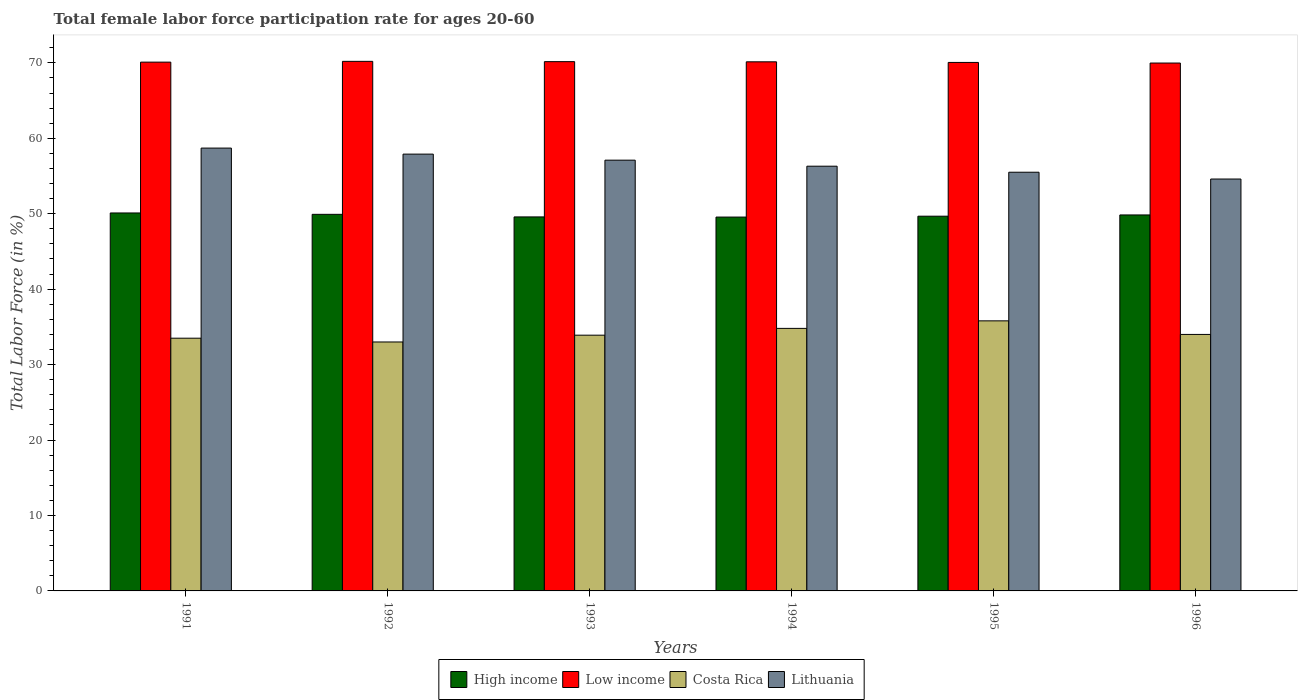How many groups of bars are there?
Provide a short and direct response. 6. Are the number of bars per tick equal to the number of legend labels?
Keep it short and to the point. Yes. Are the number of bars on each tick of the X-axis equal?
Offer a very short reply. Yes. How many bars are there on the 2nd tick from the right?
Your answer should be compact. 4. In how many cases, is the number of bars for a given year not equal to the number of legend labels?
Offer a terse response. 0. What is the female labor force participation rate in Low income in 1995?
Provide a succinct answer. 70.06. Across all years, what is the maximum female labor force participation rate in High income?
Offer a terse response. 50.1. Across all years, what is the minimum female labor force participation rate in High income?
Keep it short and to the point. 49.56. What is the total female labor force participation rate in Low income in the graph?
Your answer should be compact. 420.61. What is the difference between the female labor force participation rate in Low income in 1994 and that in 1996?
Provide a short and direct response. 0.16. What is the difference between the female labor force participation rate in Lithuania in 1991 and the female labor force participation rate in Costa Rica in 1996?
Give a very brief answer. 24.7. What is the average female labor force participation rate in Low income per year?
Make the answer very short. 70.1. In the year 1996, what is the difference between the female labor force participation rate in Lithuania and female labor force participation rate in Costa Rica?
Keep it short and to the point. 20.6. In how many years, is the female labor force participation rate in Low income greater than 12 %?
Keep it short and to the point. 6. What is the ratio of the female labor force participation rate in Low income in 1994 to that in 1996?
Make the answer very short. 1. What is the difference between the highest and the lowest female labor force participation rate in Lithuania?
Offer a terse response. 4.1. What does the 2nd bar from the left in 1991 represents?
Offer a very short reply. Low income. What does the 2nd bar from the right in 1992 represents?
Ensure brevity in your answer.  Costa Rica. Is it the case that in every year, the sum of the female labor force participation rate in High income and female labor force participation rate in Lithuania is greater than the female labor force participation rate in Costa Rica?
Offer a terse response. Yes. What is the difference between two consecutive major ticks on the Y-axis?
Provide a succinct answer. 10. Does the graph contain any zero values?
Your answer should be compact. No. Does the graph contain grids?
Make the answer very short. No. How many legend labels are there?
Offer a terse response. 4. What is the title of the graph?
Your answer should be very brief. Total female labor force participation rate for ages 20-60. Does "Gambia, The" appear as one of the legend labels in the graph?
Offer a very short reply. No. What is the label or title of the Y-axis?
Make the answer very short. Total Labor Force (in %). What is the Total Labor Force (in %) of High income in 1991?
Offer a terse response. 50.1. What is the Total Labor Force (in %) of Low income in 1991?
Keep it short and to the point. 70.09. What is the Total Labor Force (in %) in Costa Rica in 1991?
Provide a succinct answer. 33.5. What is the Total Labor Force (in %) in Lithuania in 1991?
Your answer should be compact. 58.7. What is the Total Labor Force (in %) of High income in 1992?
Provide a succinct answer. 49.92. What is the Total Labor Force (in %) of Low income in 1992?
Your answer should be very brief. 70.2. What is the Total Labor Force (in %) in Lithuania in 1992?
Give a very brief answer. 57.9. What is the Total Labor Force (in %) in High income in 1993?
Keep it short and to the point. 49.58. What is the Total Labor Force (in %) in Low income in 1993?
Provide a short and direct response. 70.16. What is the Total Labor Force (in %) of Costa Rica in 1993?
Your answer should be very brief. 33.9. What is the Total Labor Force (in %) in Lithuania in 1993?
Provide a short and direct response. 57.1. What is the Total Labor Force (in %) in High income in 1994?
Provide a short and direct response. 49.56. What is the Total Labor Force (in %) of Low income in 1994?
Ensure brevity in your answer.  70.14. What is the Total Labor Force (in %) in Costa Rica in 1994?
Provide a succinct answer. 34.8. What is the Total Labor Force (in %) in Lithuania in 1994?
Provide a short and direct response. 56.3. What is the Total Labor Force (in %) in High income in 1995?
Ensure brevity in your answer.  49.67. What is the Total Labor Force (in %) of Low income in 1995?
Give a very brief answer. 70.06. What is the Total Labor Force (in %) in Costa Rica in 1995?
Ensure brevity in your answer.  35.8. What is the Total Labor Force (in %) in Lithuania in 1995?
Your answer should be compact. 55.5. What is the Total Labor Force (in %) of High income in 1996?
Provide a succinct answer. 49.84. What is the Total Labor Force (in %) in Low income in 1996?
Your answer should be compact. 69.97. What is the Total Labor Force (in %) of Costa Rica in 1996?
Ensure brevity in your answer.  34. What is the Total Labor Force (in %) in Lithuania in 1996?
Offer a very short reply. 54.6. Across all years, what is the maximum Total Labor Force (in %) of High income?
Give a very brief answer. 50.1. Across all years, what is the maximum Total Labor Force (in %) of Low income?
Keep it short and to the point. 70.2. Across all years, what is the maximum Total Labor Force (in %) in Costa Rica?
Ensure brevity in your answer.  35.8. Across all years, what is the maximum Total Labor Force (in %) of Lithuania?
Provide a succinct answer. 58.7. Across all years, what is the minimum Total Labor Force (in %) of High income?
Make the answer very short. 49.56. Across all years, what is the minimum Total Labor Force (in %) of Low income?
Make the answer very short. 69.97. Across all years, what is the minimum Total Labor Force (in %) of Costa Rica?
Ensure brevity in your answer.  33. Across all years, what is the minimum Total Labor Force (in %) in Lithuania?
Your response must be concise. 54.6. What is the total Total Labor Force (in %) of High income in the graph?
Ensure brevity in your answer.  298.66. What is the total Total Labor Force (in %) of Low income in the graph?
Give a very brief answer. 420.61. What is the total Total Labor Force (in %) in Costa Rica in the graph?
Make the answer very short. 205. What is the total Total Labor Force (in %) in Lithuania in the graph?
Offer a very short reply. 340.1. What is the difference between the Total Labor Force (in %) of High income in 1991 and that in 1992?
Provide a succinct answer. 0.18. What is the difference between the Total Labor Force (in %) of Low income in 1991 and that in 1992?
Your response must be concise. -0.1. What is the difference between the Total Labor Force (in %) in Costa Rica in 1991 and that in 1992?
Keep it short and to the point. 0.5. What is the difference between the Total Labor Force (in %) of High income in 1991 and that in 1993?
Your answer should be compact. 0.52. What is the difference between the Total Labor Force (in %) of Low income in 1991 and that in 1993?
Keep it short and to the point. -0.06. What is the difference between the Total Labor Force (in %) in Lithuania in 1991 and that in 1993?
Ensure brevity in your answer.  1.6. What is the difference between the Total Labor Force (in %) in High income in 1991 and that in 1994?
Ensure brevity in your answer.  0.54. What is the difference between the Total Labor Force (in %) of Low income in 1991 and that in 1994?
Offer a terse response. -0.04. What is the difference between the Total Labor Force (in %) of Costa Rica in 1991 and that in 1994?
Make the answer very short. -1.3. What is the difference between the Total Labor Force (in %) in Lithuania in 1991 and that in 1994?
Give a very brief answer. 2.4. What is the difference between the Total Labor Force (in %) in High income in 1991 and that in 1995?
Keep it short and to the point. 0.43. What is the difference between the Total Labor Force (in %) of Low income in 1991 and that in 1995?
Provide a short and direct response. 0.04. What is the difference between the Total Labor Force (in %) in Costa Rica in 1991 and that in 1995?
Provide a short and direct response. -2.3. What is the difference between the Total Labor Force (in %) of High income in 1991 and that in 1996?
Ensure brevity in your answer.  0.26. What is the difference between the Total Labor Force (in %) in Low income in 1991 and that in 1996?
Offer a terse response. 0.12. What is the difference between the Total Labor Force (in %) in Costa Rica in 1991 and that in 1996?
Offer a very short reply. -0.5. What is the difference between the Total Labor Force (in %) in Lithuania in 1991 and that in 1996?
Offer a terse response. 4.1. What is the difference between the Total Labor Force (in %) in High income in 1992 and that in 1993?
Ensure brevity in your answer.  0.34. What is the difference between the Total Labor Force (in %) of Low income in 1992 and that in 1993?
Keep it short and to the point. 0.04. What is the difference between the Total Labor Force (in %) of High income in 1992 and that in 1994?
Provide a short and direct response. 0.36. What is the difference between the Total Labor Force (in %) of Low income in 1992 and that in 1994?
Keep it short and to the point. 0.06. What is the difference between the Total Labor Force (in %) of Costa Rica in 1992 and that in 1994?
Provide a succinct answer. -1.8. What is the difference between the Total Labor Force (in %) of High income in 1992 and that in 1995?
Offer a very short reply. 0.25. What is the difference between the Total Labor Force (in %) in Low income in 1992 and that in 1995?
Offer a very short reply. 0.14. What is the difference between the Total Labor Force (in %) of Costa Rica in 1992 and that in 1995?
Your response must be concise. -2.8. What is the difference between the Total Labor Force (in %) of Lithuania in 1992 and that in 1995?
Make the answer very short. 2.4. What is the difference between the Total Labor Force (in %) in High income in 1992 and that in 1996?
Your answer should be very brief. 0.08. What is the difference between the Total Labor Force (in %) of Low income in 1992 and that in 1996?
Give a very brief answer. 0.22. What is the difference between the Total Labor Force (in %) in Costa Rica in 1992 and that in 1996?
Offer a terse response. -1. What is the difference between the Total Labor Force (in %) of High income in 1993 and that in 1994?
Provide a short and direct response. 0.02. What is the difference between the Total Labor Force (in %) of Low income in 1993 and that in 1994?
Offer a terse response. 0.02. What is the difference between the Total Labor Force (in %) in Lithuania in 1993 and that in 1994?
Keep it short and to the point. 0.8. What is the difference between the Total Labor Force (in %) in High income in 1993 and that in 1995?
Your response must be concise. -0.1. What is the difference between the Total Labor Force (in %) in Low income in 1993 and that in 1995?
Provide a succinct answer. 0.1. What is the difference between the Total Labor Force (in %) in Costa Rica in 1993 and that in 1995?
Your answer should be very brief. -1.9. What is the difference between the Total Labor Force (in %) in Lithuania in 1993 and that in 1995?
Provide a short and direct response. 1.6. What is the difference between the Total Labor Force (in %) of High income in 1993 and that in 1996?
Keep it short and to the point. -0.26. What is the difference between the Total Labor Force (in %) of Low income in 1993 and that in 1996?
Give a very brief answer. 0.18. What is the difference between the Total Labor Force (in %) of High income in 1994 and that in 1995?
Your answer should be compact. -0.12. What is the difference between the Total Labor Force (in %) of Low income in 1994 and that in 1995?
Provide a succinct answer. 0.08. What is the difference between the Total Labor Force (in %) in Costa Rica in 1994 and that in 1995?
Offer a very short reply. -1. What is the difference between the Total Labor Force (in %) of Lithuania in 1994 and that in 1995?
Your answer should be very brief. 0.8. What is the difference between the Total Labor Force (in %) of High income in 1994 and that in 1996?
Give a very brief answer. -0.28. What is the difference between the Total Labor Force (in %) in Low income in 1994 and that in 1996?
Keep it short and to the point. 0.16. What is the difference between the Total Labor Force (in %) in Lithuania in 1994 and that in 1996?
Your response must be concise. 1.7. What is the difference between the Total Labor Force (in %) of High income in 1995 and that in 1996?
Your answer should be compact. -0.17. What is the difference between the Total Labor Force (in %) in Low income in 1995 and that in 1996?
Offer a very short reply. 0.08. What is the difference between the Total Labor Force (in %) of Costa Rica in 1995 and that in 1996?
Make the answer very short. 1.8. What is the difference between the Total Labor Force (in %) of High income in 1991 and the Total Labor Force (in %) of Low income in 1992?
Your response must be concise. -20.1. What is the difference between the Total Labor Force (in %) in Low income in 1991 and the Total Labor Force (in %) in Costa Rica in 1992?
Your answer should be compact. 37.09. What is the difference between the Total Labor Force (in %) of Low income in 1991 and the Total Labor Force (in %) of Lithuania in 1992?
Your response must be concise. 12.19. What is the difference between the Total Labor Force (in %) of Costa Rica in 1991 and the Total Labor Force (in %) of Lithuania in 1992?
Your response must be concise. -24.4. What is the difference between the Total Labor Force (in %) in High income in 1991 and the Total Labor Force (in %) in Low income in 1993?
Offer a very short reply. -20.06. What is the difference between the Total Labor Force (in %) in High income in 1991 and the Total Labor Force (in %) in Costa Rica in 1993?
Provide a succinct answer. 16.2. What is the difference between the Total Labor Force (in %) of Low income in 1991 and the Total Labor Force (in %) of Costa Rica in 1993?
Ensure brevity in your answer.  36.19. What is the difference between the Total Labor Force (in %) in Low income in 1991 and the Total Labor Force (in %) in Lithuania in 1993?
Give a very brief answer. 12.99. What is the difference between the Total Labor Force (in %) of Costa Rica in 1991 and the Total Labor Force (in %) of Lithuania in 1993?
Your answer should be very brief. -23.6. What is the difference between the Total Labor Force (in %) of High income in 1991 and the Total Labor Force (in %) of Low income in 1994?
Offer a very short reply. -20.04. What is the difference between the Total Labor Force (in %) in High income in 1991 and the Total Labor Force (in %) in Lithuania in 1994?
Ensure brevity in your answer.  -6.2. What is the difference between the Total Labor Force (in %) of Low income in 1991 and the Total Labor Force (in %) of Costa Rica in 1994?
Offer a terse response. 35.29. What is the difference between the Total Labor Force (in %) of Low income in 1991 and the Total Labor Force (in %) of Lithuania in 1994?
Offer a terse response. 13.79. What is the difference between the Total Labor Force (in %) of Costa Rica in 1991 and the Total Labor Force (in %) of Lithuania in 1994?
Offer a terse response. -22.8. What is the difference between the Total Labor Force (in %) of High income in 1991 and the Total Labor Force (in %) of Low income in 1995?
Offer a terse response. -19.96. What is the difference between the Total Labor Force (in %) of High income in 1991 and the Total Labor Force (in %) of Costa Rica in 1995?
Provide a short and direct response. 14.3. What is the difference between the Total Labor Force (in %) of Low income in 1991 and the Total Labor Force (in %) of Costa Rica in 1995?
Your answer should be very brief. 34.29. What is the difference between the Total Labor Force (in %) of Low income in 1991 and the Total Labor Force (in %) of Lithuania in 1995?
Offer a very short reply. 14.59. What is the difference between the Total Labor Force (in %) of High income in 1991 and the Total Labor Force (in %) of Low income in 1996?
Provide a short and direct response. -19.87. What is the difference between the Total Labor Force (in %) in High income in 1991 and the Total Labor Force (in %) in Costa Rica in 1996?
Your answer should be compact. 16.1. What is the difference between the Total Labor Force (in %) in High income in 1991 and the Total Labor Force (in %) in Lithuania in 1996?
Provide a short and direct response. -4.5. What is the difference between the Total Labor Force (in %) in Low income in 1991 and the Total Labor Force (in %) in Costa Rica in 1996?
Offer a very short reply. 36.09. What is the difference between the Total Labor Force (in %) in Low income in 1991 and the Total Labor Force (in %) in Lithuania in 1996?
Your answer should be very brief. 15.49. What is the difference between the Total Labor Force (in %) in Costa Rica in 1991 and the Total Labor Force (in %) in Lithuania in 1996?
Make the answer very short. -21.1. What is the difference between the Total Labor Force (in %) in High income in 1992 and the Total Labor Force (in %) in Low income in 1993?
Provide a succinct answer. -20.24. What is the difference between the Total Labor Force (in %) in High income in 1992 and the Total Labor Force (in %) in Costa Rica in 1993?
Your answer should be very brief. 16.02. What is the difference between the Total Labor Force (in %) of High income in 1992 and the Total Labor Force (in %) of Lithuania in 1993?
Provide a short and direct response. -7.18. What is the difference between the Total Labor Force (in %) of Low income in 1992 and the Total Labor Force (in %) of Costa Rica in 1993?
Your answer should be very brief. 36.3. What is the difference between the Total Labor Force (in %) in Low income in 1992 and the Total Labor Force (in %) in Lithuania in 1993?
Provide a succinct answer. 13.1. What is the difference between the Total Labor Force (in %) of Costa Rica in 1992 and the Total Labor Force (in %) of Lithuania in 1993?
Your response must be concise. -24.1. What is the difference between the Total Labor Force (in %) in High income in 1992 and the Total Labor Force (in %) in Low income in 1994?
Your answer should be very brief. -20.22. What is the difference between the Total Labor Force (in %) in High income in 1992 and the Total Labor Force (in %) in Costa Rica in 1994?
Make the answer very short. 15.12. What is the difference between the Total Labor Force (in %) in High income in 1992 and the Total Labor Force (in %) in Lithuania in 1994?
Offer a terse response. -6.38. What is the difference between the Total Labor Force (in %) of Low income in 1992 and the Total Labor Force (in %) of Costa Rica in 1994?
Make the answer very short. 35.4. What is the difference between the Total Labor Force (in %) of Low income in 1992 and the Total Labor Force (in %) of Lithuania in 1994?
Offer a very short reply. 13.9. What is the difference between the Total Labor Force (in %) in Costa Rica in 1992 and the Total Labor Force (in %) in Lithuania in 1994?
Your response must be concise. -23.3. What is the difference between the Total Labor Force (in %) of High income in 1992 and the Total Labor Force (in %) of Low income in 1995?
Offer a terse response. -20.14. What is the difference between the Total Labor Force (in %) of High income in 1992 and the Total Labor Force (in %) of Costa Rica in 1995?
Your response must be concise. 14.12. What is the difference between the Total Labor Force (in %) in High income in 1992 and the Total Labor Force (in %) in Lithuania in 1995?
Provide a short and direct response. -5.58. What is the difference between the Total Labor Force (in %) in Low income in 1992 and the Total Labor Force (in %) in Costa Rica in 1995?
Provide a succinct answer. 34.4. What is the difference between the Total Labor Force (in %) in Low income in 1992 and the Total Labor Force (in %) in Lithuania in 1995?
Your answer should be compact. 14.7. What is the difference between the Total Labor Force (in %) in Costa Rica in 1992 and the Total Labor Force (in %) in Lithuania in 1995?
Keep it short and to the point. -22.5. What is the difference between the Total Labor Force (in %) in High income in 1992 and the Total Labor Force (in %) in Low income in 1996?
Offer a terse response. -20.06. What is the difference between the Total Labor Force (in %) of High income in 1992 and the Total Labor Force (in %) of Costa Rica in 1996?
Offer a very short reply. 15.92. What is the difference between the Total Labor Force (in %) of High income in 1992 and the Total Labor Force (in %) of Lithuania in 1996?
Your answer should be compact. -4.68. What is the difference between the Total Labor Force (in %) in Low income in 1992 and the Total Labor Force (in %) in Costa Rica in 1996?
Your response must be concise. 36.2. What is the difference between the Total Labor Force (in %) in Low income in 1992 and the Total Labor Force (in %) in Lithuania in 1996?
Your answer should be compact. 15.6. What is the difference between the Total Labor Force (in %) in Costa Rica in 1992 and the Total Labor Force (in %) in Lithuania in 1996?
Give a very brief answer. -21.6. What is the difference between the Total Labor Force (in %) of High income in 1993 and the Total Labor Force (in %) of Low income in 1994?
Offer a terse response. -20.56. What is the difference between the Total Labor Force (in %) of High income in 1993 and the Total Labor Force (in %) of Costa Rica in 1994?
Keep it short and to the point. 14.78. What is the difference between the Total Labor Force (in %) of High income in 1993 and the Total Labor Force (in %) of Lithuania in 1994?
Keep it short and to the point. -6.72. What is the difference between the Total Labor Force (in %) in Low income in 1993 and the Total Labor Force (in %) in Costa Rica in 1994?
Provide a short and direct response. 35.36. What is the difference between the Total Labor Force (in %) of Low income in 1993 and the Total Labor Force (in %) of Lithuania in 1994?
Offer a terse response. 13.86. What is the difference between the Total Labor Force (in %) of Costa Rica in 1993 and the Total Labor Force (in %) of Lithuania in 1994?
Give a very brief answer. -22.4. What is the difference between the Total Labor Force (in %) in High income in 1993 and the Total Labor Force (in %) in Low income in 1995?
Offer a terse response. -20.48. What is the difference between the Total Labor Force (in %) in High income in 1993 and the Total Labor Force (in %) in Costa Rica in 1995?
Offer a terse response. 13.78. What is the difference between the Total Labor Force (in %) in High income in 1993 and the Total Labor Force (in %) in Lithuania in 1995?
Keep it short and to the point. -5.92. What is the difference between the Total Labor Force (in %) of Low income in 1993 and the Total Labor Force (in %) of Costa Rica in 1995?
Provide a succinct answer. 34.36. What is the difference between the Total Labor Force (in %) in Low income in 1993 and the Total Labor Force (in %) in Lithuania in 1995?
Your answer should be compact. 14.66. What is the difference between the Total Labor Force (in %) in Costa Rica in 1993 and the Total Labor Force (in %) in Lithuania in 1995?
Provide a succinct answer. -21.6. What is the difference between the Total Labor Force (in %) in High income in 1993 and the Total Labor Force (in %) in Low income in 1996?
Offer a terse response. -20.4. What is the difference between the Total Labor Force (in %) of High income in 1993 and the Total Labor Force (in %) of Costa Rica in 1996?
Offer a terse response. 15.58. What is the difference between the Total Labor Force (in %) of High income in 1993 and the Total Labor Force (in %) of Lithuania in 1996?
Keep it short and to the point. -5.02. What is the difference between the Total Labor Force (in %) in Low income in 1993 and the Total Labor Force (in %) in Costa Rica in 1996?
Keep it short and to the point. 36.16. What is the difference between the Total Labor Force (in %) in Low income in 1993 and the Total Labor Force (in %) in Lithuania in 1996?
Your answer should be very brief. 15.56. What is the difference between the Total Labor Force (in %) of Costa Rica in 1993 and the Total Labor Force (in %) of Lithuania in 1996?
Give a very brief answer. -20.7. What is the difference between the Total Labor Force (in %) in High income in 1994 and the Total Labor Force (in %) in Low income in 1995?
Offer a very short reply. -20.5. What is the difference between the Total Labor Force (in %) in High income in 1994 and the Total Labor Force (in %) in Costa Rica in 1995?
Offer a terse response. 13.76. What is the difference between the Total Labor Force (in %) of High income in 1994 and the Total Labor Force (in %) of Lithuania in 1995?
Your answer should be compact. -5.94. What is the difference between the Total Labor Force (in %) of Low income in 1994 and the Total Labor Force (in %) of Costa Rica in 1995?
Provide a succinct answer. 34.34. What is the difference between the Total Labor Force (in %) of Low income in 1994 and the Total Labor Force (in %) of Lithuania in 1995?
Keep it short and to the point. 14.64. What is the difference between the Total Labor Force (in %) of Costa Rica in 1994 and the Total Labor Force (in %) of Lithuania in 1995?
Offer a terse response. -20.7. What is the difference between the Total Labor Force (in %) in High income in 1994 and the Total Labor Force (in %) in Low income in 1996?
Offer a very short reply. -20.42. What is the difference between the Total Labor Force (in %) in High income in 1994 and the Total Labor Force (in %) in Costa Rica in 1996?
Offer a very short reply. 15.56. What is the difference between the Total Labor Force (in %) in High income in 1994 and the Total Labor Force (in %) in Lithuania in 1996?
Ensure brevity in your answer.  -5.04. What is the difference between the Total Labor Force (in %) of Low income in 1994 and the Total Labor Force (in %) of Costa Rica in 1996?
Make the answer very short. 36.14. What is the difference between the Total Labor Force (in %) in Low income in 1994 and the Total Labor Force (in %) in Lithuania in 1996?
Provide a succinct answer. 15.54. What is the difference between the Total Labor Force (in %) of Costa Rica in 1994 and the Total Labor Force (in %) of Lithuania in 1996?
Provide a succinct answer. -19.8. What is the difference between the Total Labor Force (in %) in High income in 1995 and the Total Labor Force (in %) in Low income in 1996?
Your response must be concise. -20.3. What is the difference between the Total Labor Force (in %) in High income in 1995 and the Total Labor Force (in %) in Costa Rica in 1996?
Ensure brevity in your answer.  15.67. What is the difference between the Total Labor Force (in %) in High income in 1995 and the Total Labor Force (in %) in Lithuania in 1996?
Make the answer very short. -4.93. What is the difference between the Total Labor Force (in %) in Low income in 1995 and the Total Labor Force (in %) in Costa Rica in 1996?
Provide a succinct answer. 36.06. What is the difference between the Total Labor Force (in %) in Low income in 1995 and the Total Labor Force (in %) in Lithuania in 1996?
Ensure brevity in your answer.  15.46. What is the difference between the Total Labor Force (in %) of Costa Rica in 1995 and the Total Labor Force (in %) of Lithuania in 1996?
Provide a succinct answer. -18.8. What is the average Total Labor Force (in %) of High income per year?
Give a very brief answer. 49.78. What is the average Total Labor Force (in %) in Low income per year?
Provide a succinct answer. 70.1. What is the average Total Labor Force (in %) in Costa Rica per year?
Give a very brief answer. 34.17. What is the average Total Labor Force (in %) in Lithuania per year?
Your answer should be compact. 56.68. In the year 1991, what is the difference between the Total Labor Force (in %) of High income and Total Labor Force (in %) of Low income?
Offer a terse response. -19.99. In the year 1991, what is the difference between the Total Labor Force (in %) of Low income and Total Labor Force (in %) of Costa Rica?
Make the answer very short. 36.59. In the year 1991, what is the difference between the Total Labor Force (in %) in Low income and Total Labor Force (in %) in Lithuania?
Your response must be concise. 11.39. In the year 1991, what is the difference between the Total Labor Force (in %) of Costa Rica and Total Labor Force (in %) of Lithuania?
Provide a succinct answer. -25.2. In the year 1992, what is the difference between the Total Labor Force (in %) in High income and Total Labor Force (in %) in Low income?
Your answer should be very brief. -20.28. In the year 1992, what is the difference between the Total Labor Force (in %) in High income and Total Labor Force (in %) in Costa Rica?
Make the answer very short. 16.92. In the year 1992, what is the difference between the Total Labor Force (in %) of High income and Total Labor Force (in %) of Lithuania?
Your response must be concise. -7.98. In the year 1992, what is the difference between the Total Labor Force (in %) in Low income and Total Labor Force (in %) in Costa Rica?
Keep it short and to the point. 37.2. In the year 1992, what is the difference between the Total Labor Force (in %) in Low income and Total Labor Force (in %) in Lithuania?
Your answer should be very brief. 12.3. In the year 1992, what is the difference between the Total Labor Force (in %) in Costa Rica and Total Labor Force (in %) in Lithuania?
Your answer should be very brief. -24.9. In the year 1993, what is the difference between the Total Labor Force (in %) of High income and Total Labor Force (in %) of Low income?
Offer a terse response. -20.58. In the year 1993, what is the difference between the Total Labor Force (in %) in High income and Total Labor Force (in %) in Costa Rica?
Provide a short and direct response. 15.68. In the year 1993, what is the difference between the Total Labor Force (in %) of High income and Total Labor Force (in %) of Lithuania?
Your response must be concise. -7.52. In the year 1993, what is the difference between the Total Labor Force (in %) of Low income and Total Labor Force (in %) of Costa Rica?
Your answer should be very brief. 36.26. In the year 1993, what is the difference between the Total Labor Force (in %) of Low income and Total Labor Force (in %) of Lithuania?
Provide a succinct answer. 13.06. In the year 1993, what is the difference between the Total Labor Force (in %) of Costa Rica and Total Labor Force (in %) of Lithuania?
Provide a short and direct response. -23.2. In the year 1994, what is the difference between the Total Labor Force (in %) in High income and Total Labor Force (in %) in Low income?
Make the answer very short. -20.58. In the year 1994, what is the difference between the Total Labor Force (in %) in High income and Total Labor Force (in %) in Costa Rica?
Ensure brevity in your answer.  14.76. In the year 1994, what is the difference between the Total Labor Force (in %) in High income and Total Labor Force (in %) in Lithuania?
Make the answer very short. -6.74. In the year 1994, what is the difference between the Total Labor Force (in %) in Low income and Total Labor Force (in %) in Costa Rica?
Make the answer very short. 35.34. In the year 1994, what is the difference between the Total Labor Force (in %) of Low income and Total Labor Force (in %) of Lithuania?
Provide a short and direct response. 13.84. In the year 1994, what is the difference between the Total Labor Force (in %) of Costa Rica and Total Labor Force (in %) of Lithuania?
Keep it short and to the point. -21.5. In the year 1995, what is the difference between the Total Labor Force (in %) in High income and Total Labor Force (in %) in Low income?
Ensure brevity in your answer.  -20.38. In the year 1995, what is the difference between the Total Labor Force (in %) of High income and Total Labor Force (in %) of Costa Rica?
Ensure brevity in your answer.  13.87. In the year 1995, what is the difference between the Total Labor Force (in %) in High income and Total Labor Force (in %) in Lithuania?
Provide a short and direct response. -5.83. In the year 1995, what is the difference between the Total Labor Force (in %) of Low income and Total Labor Force (in %) of Costa Rica?
Give a very brief answer. 34.26. In the year 1995, what is the difference between the Total Labor Force (in %) of Low income and Total Labor Force (in %) of Lithuania?
Your response must be concise. 14.56. In the year 1995, what is the difference between the Total Labor Force (in %) in Costa Rica and Total Labor Force (in %) in Lithuania?
Your response must be concise. -19.7. In the year 1996, what is the difference between the Total Labor Force (in %) in High income and Total Labor Force (in %) in Low income?
Give a very brief answer. -20.14. In the year 1996, what is the difference between the Total Labor Force (in %) in High income and Total Labor Force (in %) in Costa Rica?
Provide a short and direct response. 15.84. In the year 1996, what is the difference between the Total Labor Force (in %) of High income and Total Labor Force (in %) of Lithuania?
Your answer should be very brief. -4.76. In the year 1996, what is the difference between the Total Labor Force (in %) in Low income and Total Labor Force (in %) in Costa Rica?
Keep it short and to the point. 35.97. In the year 1996, what is the difference between the Total Labor Force (in %) in Low income and Total Labor Force (in %) in Lithuania?
Provide a succinct answer. 15.37. In the year 1996, what is the difference between the Total Labor Force (in %) of Costa Rica and Total Labor Force (in %) of Lithuania?
Your response must be concise. -20.6. What is the ratio of the Total Labor Force (in %) in High income in 1991 to that in 1992?
Provide a succinct answer. 1. What is the ratio of the Total Labor Force (in %) in Low income in 1991 to that in 1992?
Provide a succinct answer. 1. What is the ratio of the Total Labor Force (in %) in Costa Rica in 1991 to that in 1992?
Give a very brief answer. 1.02. What is the ratio of the Total Labor Force (in %) of Lithuania in 1991 to that in 1992?
Offer a very short reply. 1.01. What is the ratio of the Total Labor Force (in %) in High income in 1991 to that in 1993?
Offer a very short reply. 1.01. What is the ratio of the Total Labor Force (in %) of Lithuania in 1991 to that in 1993?
Your answer should be compact. 1.03. What is the ratio of the Total Labor Force (in %) of Costa Rica in 1991 to that in 1994?
Ensure brevity in your answer.  0.96. What is the ratio of the Total Labor Force (in %) in Lithuania in 1991 to that in 1994?
Your answer should be very brief. 1.04. What is the ratio of the Total Labor Force (in %) in High income in 1991 to that in 1995?
Give a very brief answer. 1.01. What is the ratio of the Total Labor Force (in %) in Low income in 1991 to that in 1995?
Offer a terse response. 1. What is the ratio of the Total Labor Force (in %) of Costa Rica in 1991 to that in 1995?
Offer a very short reply. 0.94. What is the ratio of the Total Labor Force (in %) in Lithuania in 1991 to that in 1995?
Provide a short and direct response. 1.06. What is the ratio of the Total Labor Force (in %) of High income in 1991 to that in 1996?
Make the answer very short. 1.01. What is the ratio of the Total Labor Force (in %) of Low income in 1991 to that in 1996?
Ensure brevity in your answer.  1. What is the ratio of the Total Labor Force (in %) in Costa Rica in 1991 to that in 1996?
Provide a short and direct response. 0.99. What is the ratio of the Total Labor Force (in %) in Lithuania in 1991 to that in 1996?
Give a very brief answer. 1.08. What is the ratio of the Total Labor Force (in %) in High income in 1992 to that in 1993?
Keep it short and to the point. 1.01. What is the ratio of the Total Labor Force (in %) of Low income in 1992 to that in 1993?
Provide a short and direct response. 1. What is the ratio of the Total Labor Force (in %) in Costa Rica in 1992 to that in 1993?
Ensure brevity in your answer.  0.97. What is the ratio of the Total Labor Force (in %) in High income in 1992 to that in 1994?
Give a very brief answer. 1.01. What is the ratio of the Total Labor Force (in %) in Costa Rica in 1992 to that in 1994?
Your answer should be compact. 0.95. What is the ratio of the Total Labor Force (in %) of Lithuania in 1992 to that in 1994?
Keep it short and to the point. 1.03. What is the ratio of the Total Labor Force (in %) of High income in 1992 to that in 1995?
Your response must be concise. 1. What is the ratio of the Total Labor Force (in %) of Low income in 1992 to that in 1995?
Make the answer very short. 1. What is the ratio of the Total Labor Force (in %) of Costa Rica in 1992 to that in 1995?
Ensure brevity in your answer.  0.92. What is the ratio of the Total Labor Force (in %) of Lithuania in 1992 to that in 1995?
Your answer should be compact. 1.04. What is the ratio of the Total Labor Force (in %) in High income in 1992 to that in 1996?
Offer a very short reply. 1. What is the ratio of the Total Labor Force (in %) in Costa Rica in 1992 to that in 1996?
Offer a very short reply. 0.97. What is the ratio of the Total Labor Force (in %) in Lithuania in 1992 to that in 1996?
Your answer should be compact. 1.06. What is the ratio of the Total Labor Force (in %) of High income in 1993 to that in 1994?
Your response must be concise. 1. What is the ratio of the Total Labor Force (in %) of Costa Rica in 1993 to that in 1994?
Offer a terse response. 0.97. What is the ratio of the Total Labor Force (in %) of Lithuania in 1993 to that in 1994?
Your response must be concise. 1.01. What is the ratio of the Total Labor Force (in %) in High income in 1993 to that in 1995?
Offer a terse response. 1. What is the ratio of the Total Labor Force (in %) in Costa Rica in 1993 to that in 1995?
Your response must be concise. 0.95. What is the ratio of the Total Labor Force (in %) in Lithuania in 1993 to that in 1995?
Provide a succinct answer. 1.03. What is the ratio of the Total Labor Force (in %) of High income in 1993 to that in 1996?
Provide a short and direct response. 0.99. What is the ratio of the Total Labor Force (in %) of Costa Rica in 1993 to that in 1996?
Your answer should be compact. 1. What is the ratio of the Total Labor Force (in %) in Lithuania in 1993 to that in 1996?
Provide a short and direct response. 1.05. What is the ratio of the Total Labor Force (in %) in Low income in 1994 to that in 1995?
Make the answer very short. 1. What is the ratio of the Total Labor Force (in %) of Costa Rica in 1994 to that in 1995?
Provide a short and direct response. 0.97. What is the ratio of the Total Labor Force (in %) of Lithuania in 1994 to that in 1995?
Make the answer very short. 1.01. What is the ratio of the Total Labor Force (in %) in High income in 1994 to that in 1996?
Your answer should be very brief. 0.99. What is the ratio of the Total Labor Force (in %) of Low income in 1994 to that in 1996?
Ensure brevity in your answer.  1. What is the ratio of the Total Labor Force (in %) in Costa Rica in 1994 to that in 1996?
Keep it short and to the point. 1.02. What is the ratio of the Total Labor Force (in %) in Lithuania in 1994 to that in 1996?
Your answer should be very brief. 1.03. What is the ratio of the Total Labor Force (in %) of Low income in 1995 to that in 1996?
Offer a terse response. 1. What is the ratio of the Total Labor Force (in %) in Costa Rica in 1995 to that in 1996?
Offer a very short reply. 1.05. What is the ratio of the Total Labor Force (in %) of Lithuania in 1995 to that in 1996?
Offer a very short reply. 1.02. What is the difference between the highest and the second highest Total Labor Force (in %) in High income?
Keep it short and to the point. 0.18. What is the difference between the highest and the second highest Total Labor Force (in %) of Low income?
Provide a succinct answer. 0.04. What is the difference between the highest and the lowest Total Labor Force (in %) of High income?
Your response must be concise. 0.54. What is the difference between the highest and the lowest Total Labor Force (in %) of Low income?
Your response must be concise. 0.22. What is the difference between the highest and the lowest Total Labor Force (in %) of Lithuania?
Provide a succinct answer. 4.1. 